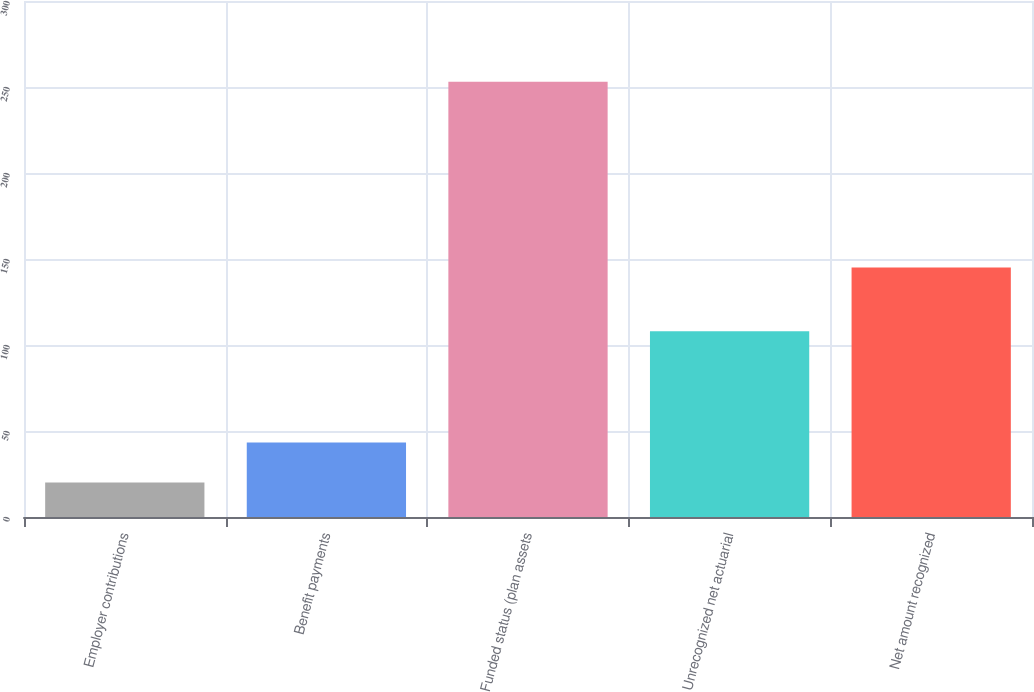Convert chart to OTSL. <chart><loc_0><loc_0><loc_500><loc_500><bar_chart><fcel>Employer contributions<fcel>Benefit payments<fcel>Funded status (plan assets<fcel>Unrecognized net actuarial<fcel>Net amount recognized<nl><fcel>20<fcel>43.3<fcel>253<fcel>108<fcel>145<nl></chart> 